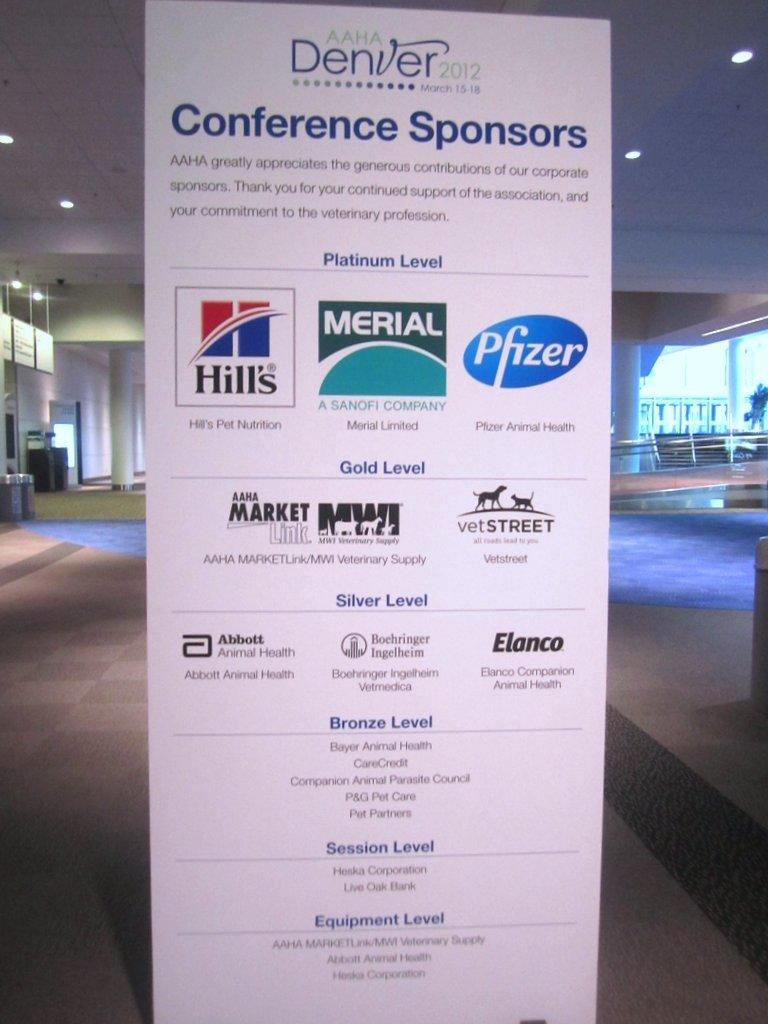<image>
Summarize the visual content of the image. A giant signage with many different names from a conference sponsorship in Denver. 